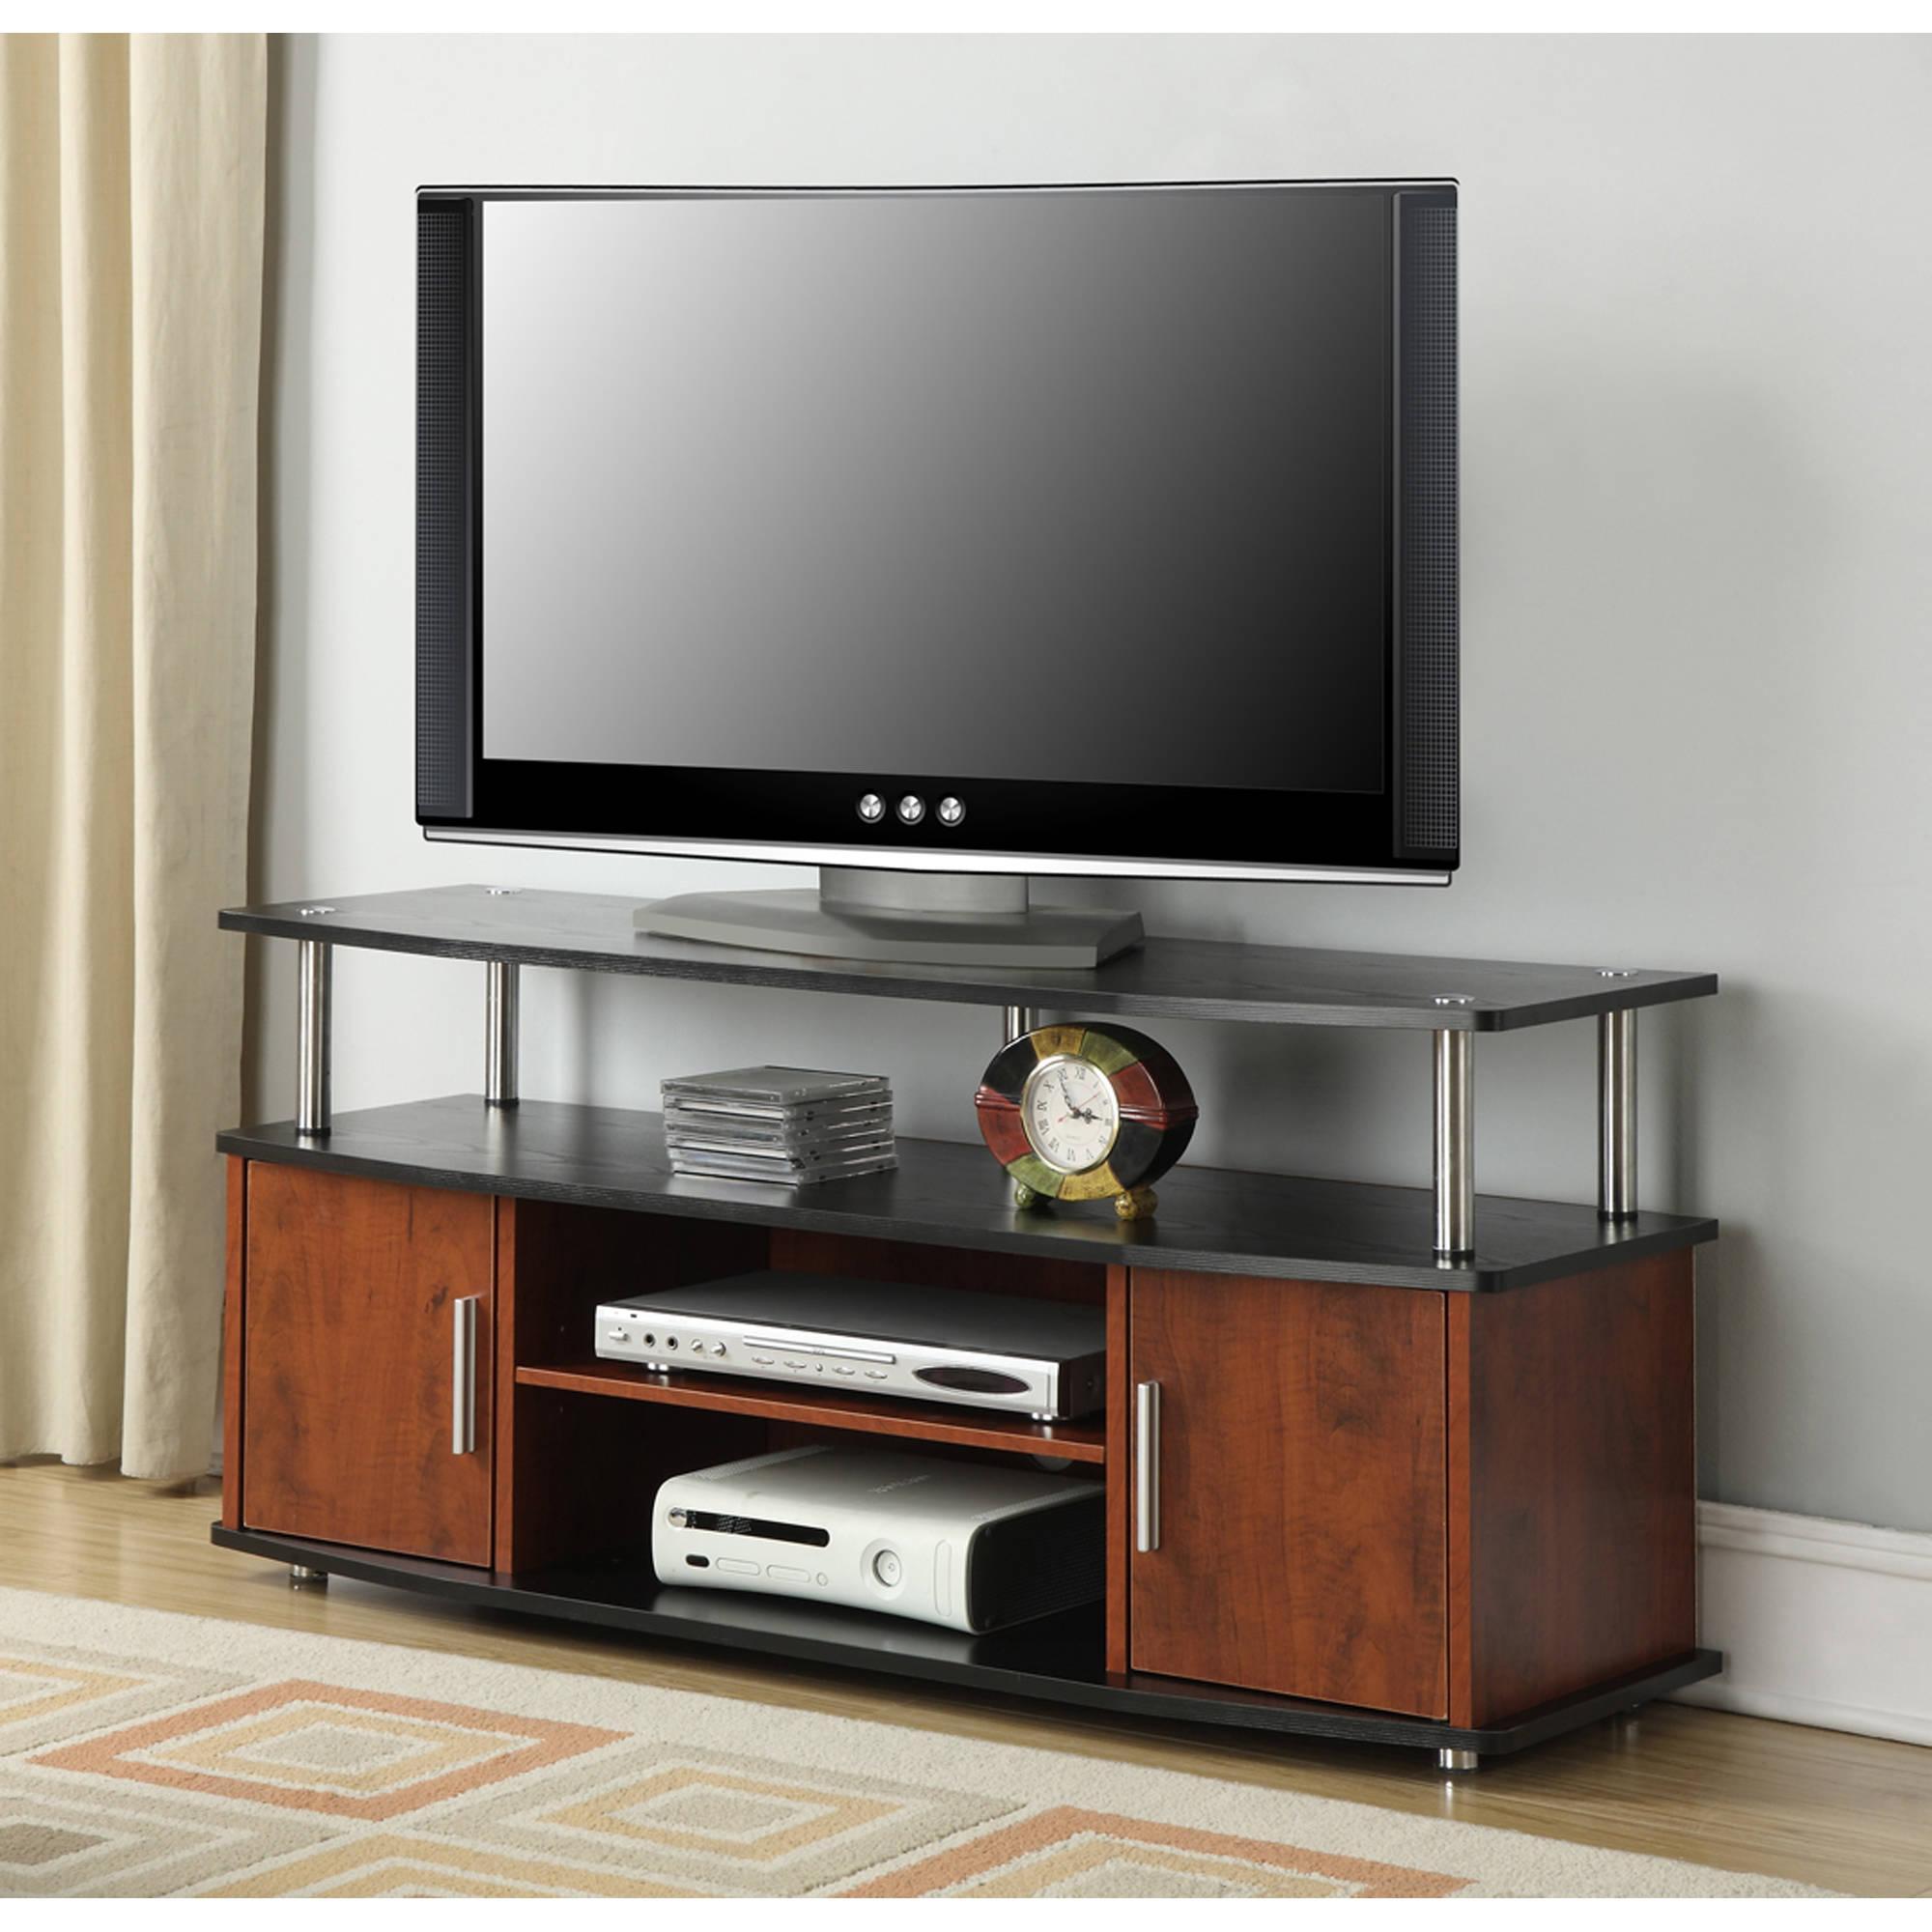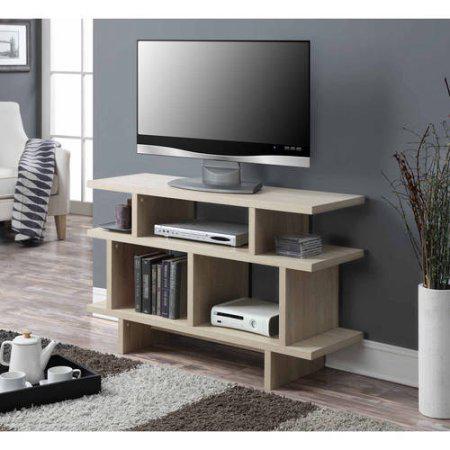The first image is the image on the left, the second image is the image on the right. For the images shown, is this caption "Only one of the televisions appears to be reflecting light; the other tv is completely dark." true? Answer yes or no. No. The first image is the image on the left, the second image is the image on the right. For the images displayed, is the sentence "There is a lamp near the television in the image on the right." factually correct? Answer yes or no. No. 